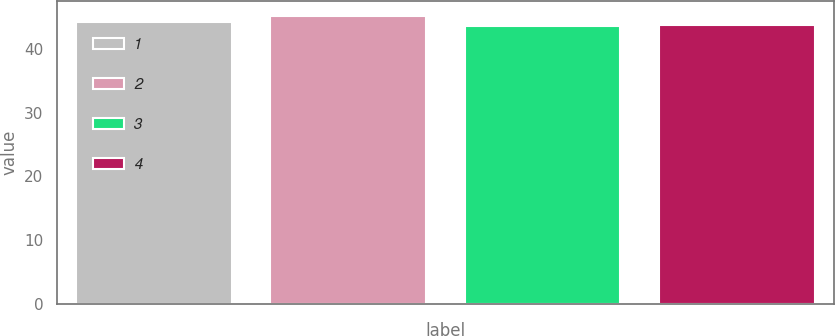<chart> <loc_0><loc_0><loc_500><loc_500><bar_chart><fcel>1<fcel>2<fcel>3<fcel>4<nl><fcel>44.32<fcel>45.23<fcel>43.68<fcel>43.84<nl></chart> 